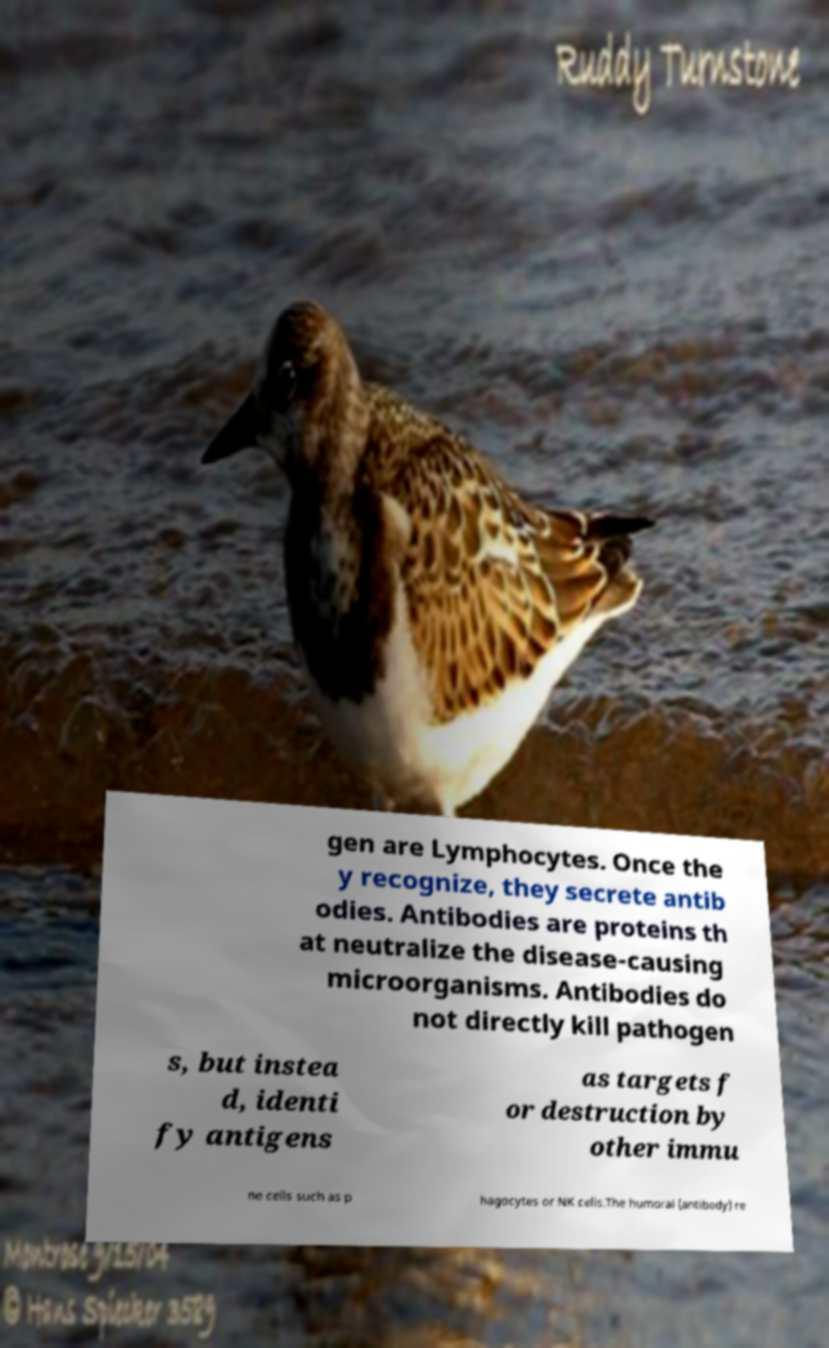Can you accurately transcribe the text from the provided image for me? gen are Lymphocytes. Once the y recognize, they secrete antib odies. Antibodies are proteins th at neutralize the disease-causing microorganisms. Antibodies do not directly kill pathogen s, but instea d, identi fy antigens as targets f or destruction by other immu ne cells such as p hagocytes or NK cells.The humoral (antibody) re 